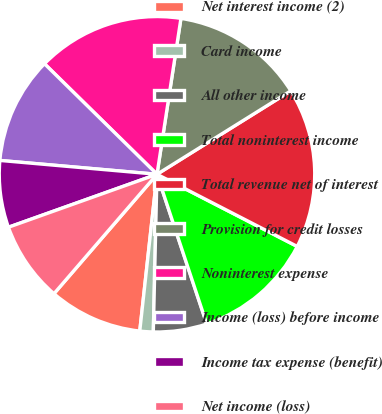Convert chart to OTSL. <chart><loc_0><loc_0><loc_500><loc_500><pie_chart><fcel>Net interest income (2)<fcel>Card income<fcel>All other income<fcel>Total noninterest income<fcel>Total revenue net of interest<fcel>Provision for credit losses<fcel>Noninterest expense<fcel>Income (loss) before income<fcel>Income tax expense (benefit)<fcel>Net income (loss)<nl><fcel>9.59%<fcel>1.37%<fcel>5.48%<fcel>12.33%<fcel>16.44%<fcel>13.7%<fcel>15.07%<fcel>10.96%<fcel>6.85%<fcel>8.22%<nl></chart> 